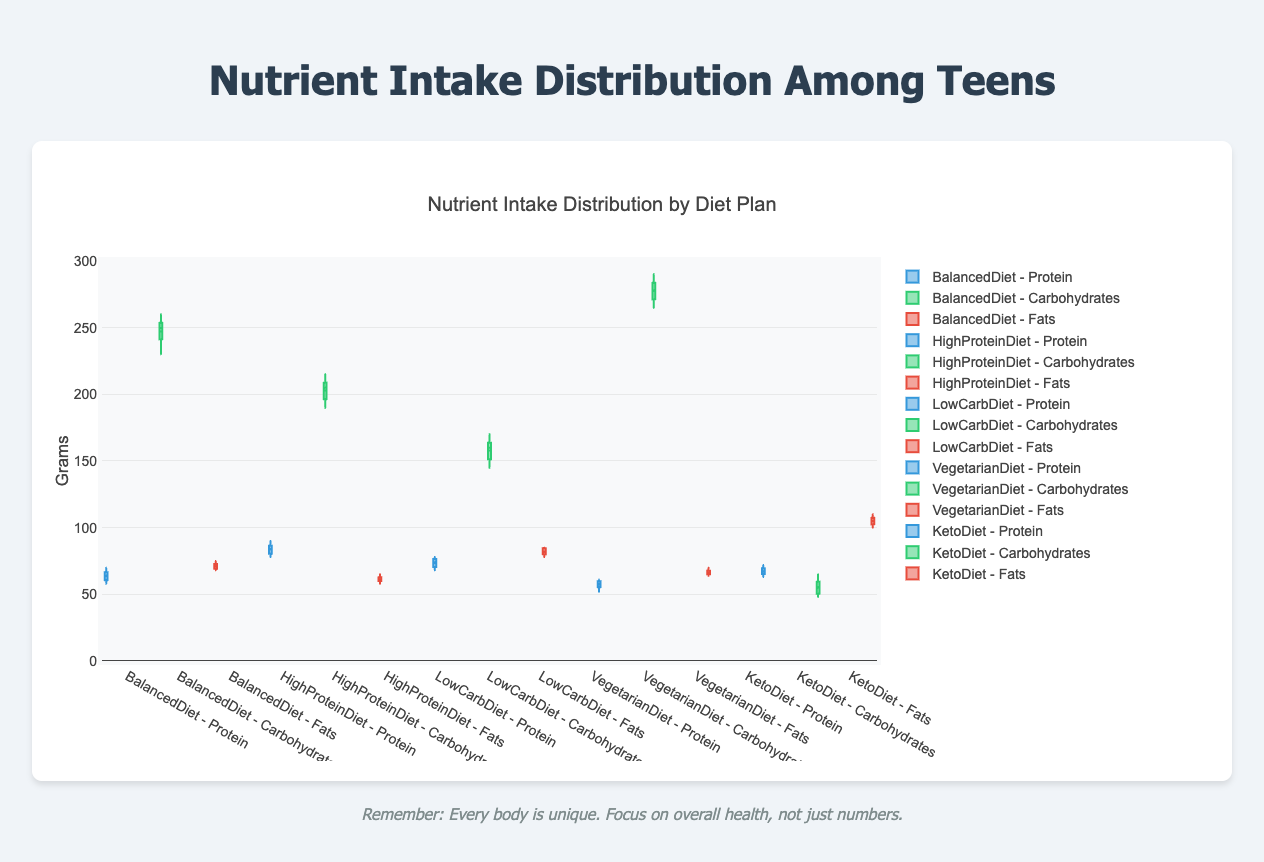what is the title of the figure? The title is usually at the top of the figure, summarizing what the plotted data represents. In this case, the title is "Nutrient Intake Distribution by Diet Plan".
Answer: Nutrient Intake Distribution by Diet Plan What nutrient has the highest median value in the Keto Diet? To find this, look at the middle lines of the boxes for the Keto Diet group. The highest median value belongs to Fats.
Answer: Fats Which diet plan shows the widest range (highest to lowest) for carbohydrate intake? The widest range can be identified by the length of the box-and-whisker plot for carbohydrates. The Vegetarian Diet shows the widest range.
Answer: Vegetarian Diet What is the approximate median protein intake for the High Protein Diet? The median value in a box plot is marked by the line inside the box. For the High Protein Diet, the median protein intake is about 82 grams.
Answer: 82 grams Which diet plan has the lowest variability in fat intake? Variability is shown by the length of the box as well as the whiskers. The High Protein Diet has the shortest box and whiskers for fats, indicating the lowest variability.
Answer: High Protein Diet How do the fat levels compare between the Keto Diet and the Balanced Diet? By looking at the median lines and the range of the boxes for fats in both diets, the fat levels are higher and more varied in the Keto Diet compared to the Balanced Diet.
Answer: Higher and more varied in Keto Diet What is the upper whisker value of carbohydrates in the Low Carb Diet? The upper whisker shows the highest value excluding outliers. For Low Carb Diet carbohydrates, this value is roughly 170 grams.
Answer: 170 grams What is the interquartile range (IQR) of protein intake in the Balanced Diet? The IQR is found by subtracting the first quartile from the third quartile. Visually, it is the height of the box. For the Balanced Diet's protein, the IQR is from approximately 60 to 67 grams, so 67 - 60 = 7 grams.
Answer: 7 grams Which diet plan has the longest whisker for fats, indicating it contains outliers? By observing the whiskers' length, the Keto Diet has the longest whiskers for fats, indicating it includes outliers.
Answer: Keto Diet 